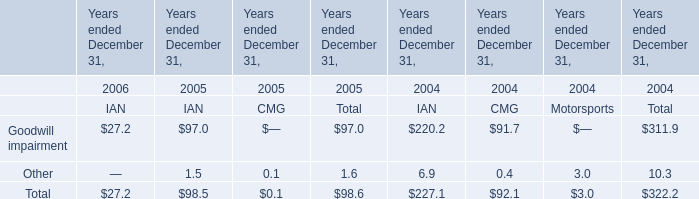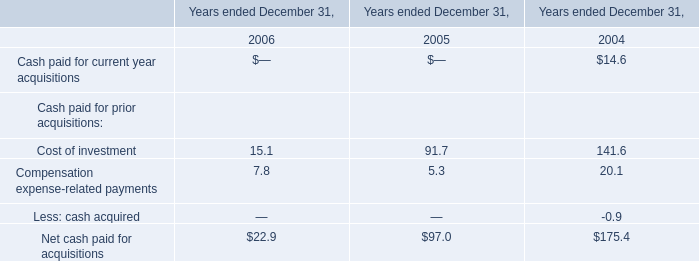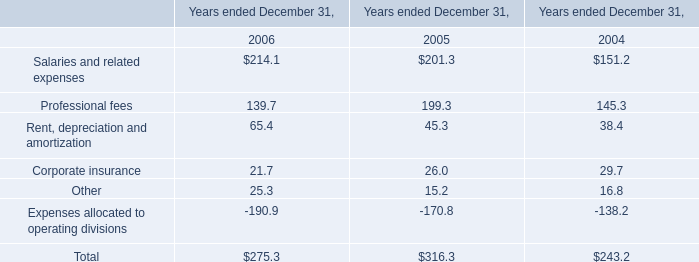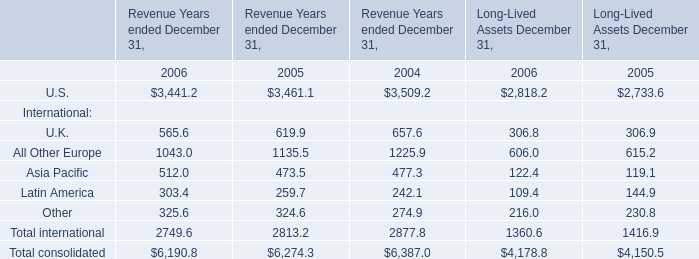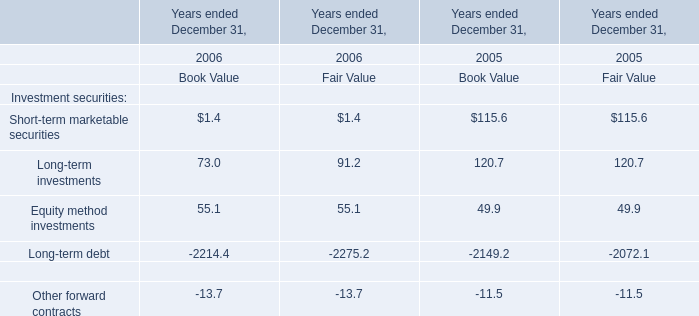What was the total amount of Salaries and related expenses and Professional fees in 2006 ? 
Computations: (214.1 + 139.7)
Answer: 353.8. 